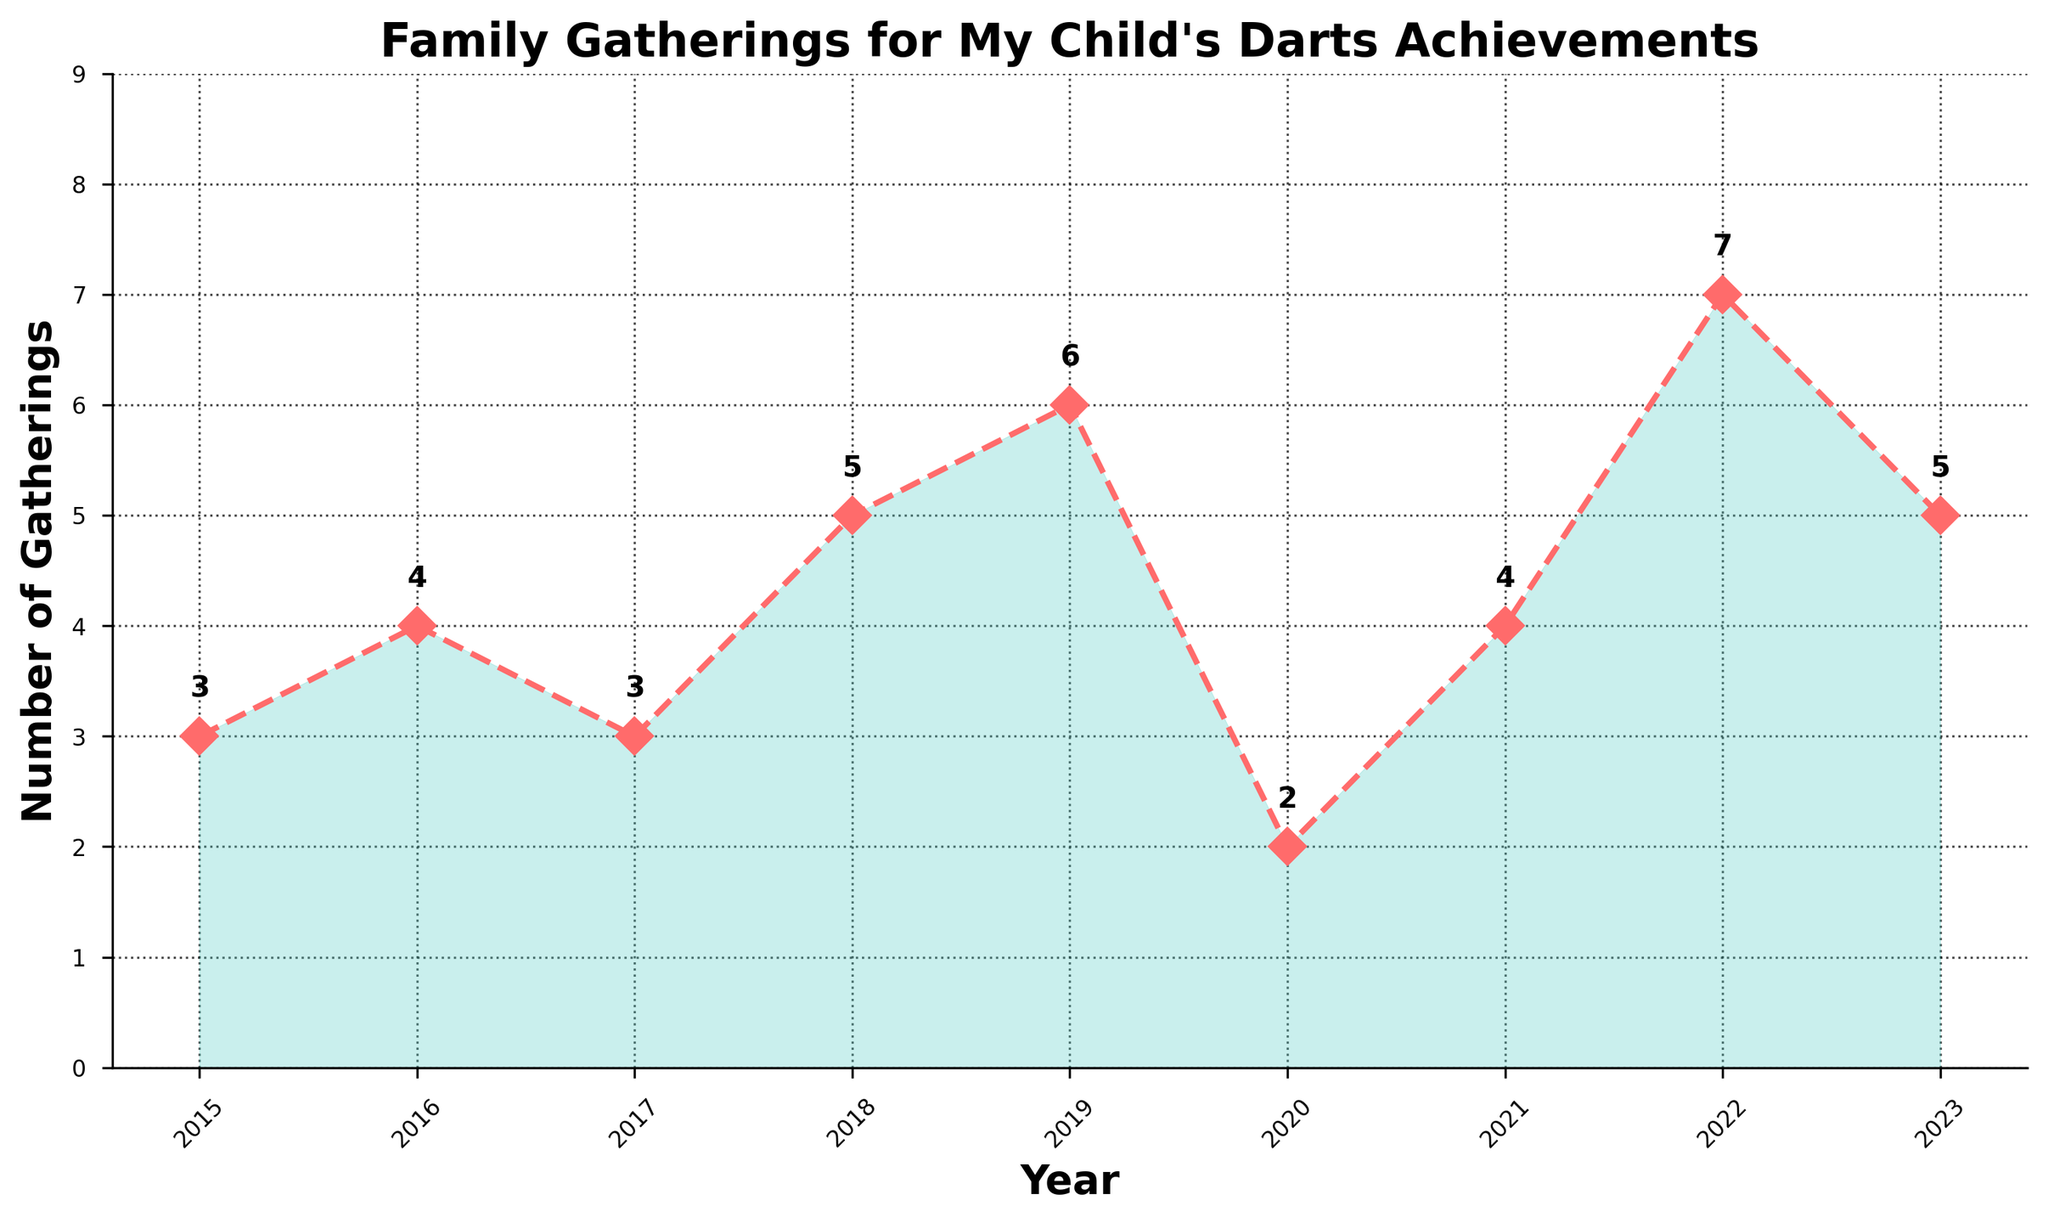What is the title of the plot? The plot's text header, located above the graph, is the title. It reads "Family Gatherings for My Child's Darts Achievements."
Answer: Family Gatherings for My Child's Darts Achievements How many family gatherings were there in 2019? By locating the year 2019 on the x-axis and following it vertically to the data point, you will see the label indicating the number of gatherings.
Answer: 6 In which year were the number of gatherings the highest? Find the peak of the plotted line and look for the corresponding year on the x-axis. It shows the highest point in 2022.
Answer: 2022 How did the number of gatherings change from 2020 to 2021? Compare the numbers of gatherings between 2020 and 2021 on the x-axis and observe if the value increased, decreased, or stayed the same. The plot shows an increase from 2 to 4 gatherings.
Answer: increased What is the average number of family gatherings over the years? Sum all the values for the number of gatherings (3+4+3+5+6+2+4+7+5) which equals 39. Divide this by the number of years (9). 39 / 9 equals approximately 4.33.
Answer: 4.33 Which year had the smallest number of gatherings, and how many were there? Identify the lowest point on the graph and find the corresponding year on the x-axis. The year 2020 had the smallest number of gatherings, which is 2.
Answer: 2020, 2 Is there a trend in the number of gatherings from 2015 to 2023? Look at the overall direction of the line plot from 2015 to 2023. Generally, the trend shows an increase, despite some fluctuations.
Answer: increasing What was the difference in the number of gatherings between the year with the highest and the year with the lowest gatherings? Locate the highest (2022, 7 gatherings) and lowest (2020, 2 gatherings) points on the graph. The difference is 7 - 2, which equals 5.
Answer: 5 How did the number of gatherings in 2017 compare to 2018? Look at the data points for 2017 and 2018. In 2017, there were 3 gatherings, and in 2018, there were 5 gatherings, so 2018 had more.
Answer: 2018 had more How many years had more than 4 gatherings? Count the number of years where the number of gatherings exceeds 4 by looking at the graph. The years are 2018, 2019, 2022, and 2023, which makes 4 years.
Answer: 4 